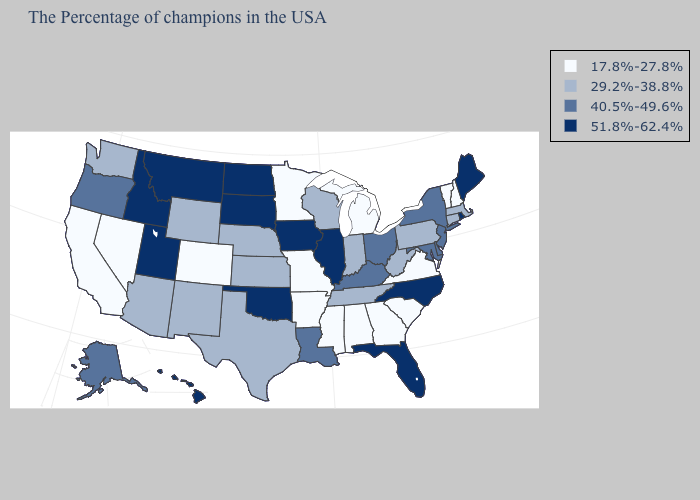Which states hav the highest value in the Northeast?
Short answer required. Maine, Rhode Island. Which states have the lowest value in the Northeast?
Answer briefly. New Hampshire, Vermont. What is the value of Massachusetts?
Answer briefly. 29.2%-38.8%. Name the states that have a value in the range 29.2%-38.8%?
Answer briefly. Massachusetts, Connecticut, Pennsylvania, West Virginia, Indiana, Tennessee, Wisconsin, Kansas, Nebraska, Texas, Wyoming, New Mexico, Arizona, Washington. Name the states that have a value in the range 17.8%-27.8%?
Write a very short answer. New Hampshire, Vermont, Virginia, South Carolina, Georgia, Michigan, Alabama, Mississippi, Missouri, Arkansas, Minnesota, Colorado, Nevada, California. Does Hawaii have the highest value in the West?
Give a very brief answer. Yes. Name the states that have a value in the range 51.8%-62.4%?
Quick response, please. Maine, Rhode Island, North Carolina, Florida, Illinois, Iowa, Oklahoma, South Dakota, North Dakota, Utah, Montana, Idaho, Hawaii. Does the first symbol in the legend represent the smallest category?
Write a very short answer. Yes. Name the states that have a value in the range 40.5%-49.6%?
Give a very brief answer. New York, New Jersey, Delaware, Maryland, Ohio, Kentucky, Louisiana, Oregon, Alaska. Does Washington have the same value as Massachusetts?
Short answer required. Yes. Does Rhode Island have the highest value in the USA?
Be succinct. Yes. Name the states that have a value in the range 40.5%-49.6%?
Concise answer only. New York, New Jersey, Delaware, Maryland, Ohio, Kentucky, Louisiana, Oregon, Alaska. Does Tennessee have a lower value than Delaware?
Short answer required. Yes. What is the value of Colorado?
Answer briefly. 17.8%-27.8%. What is the value of Connecticut?
Concise answer only. 29.2%-38.8%. 